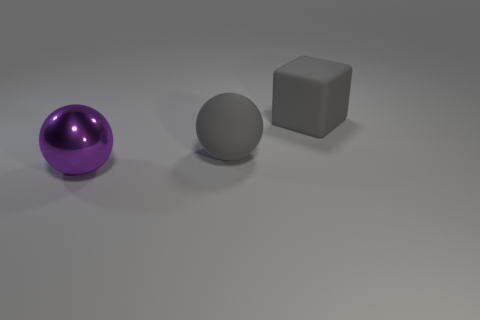Add 2 big gray cubes. How many objects exist? 5 Subtract all spheres. How many objects are left? 1 Add 3 rubber cubes. How many rubber cubes exist? 4 Subtract 0 green cylinders. How many objects are left? 3 Subtract all red shiny spheres. Subtract all large purple things. How many objects are left? 2 Add 2 matte blocks. How many matte blocks are left? 3 